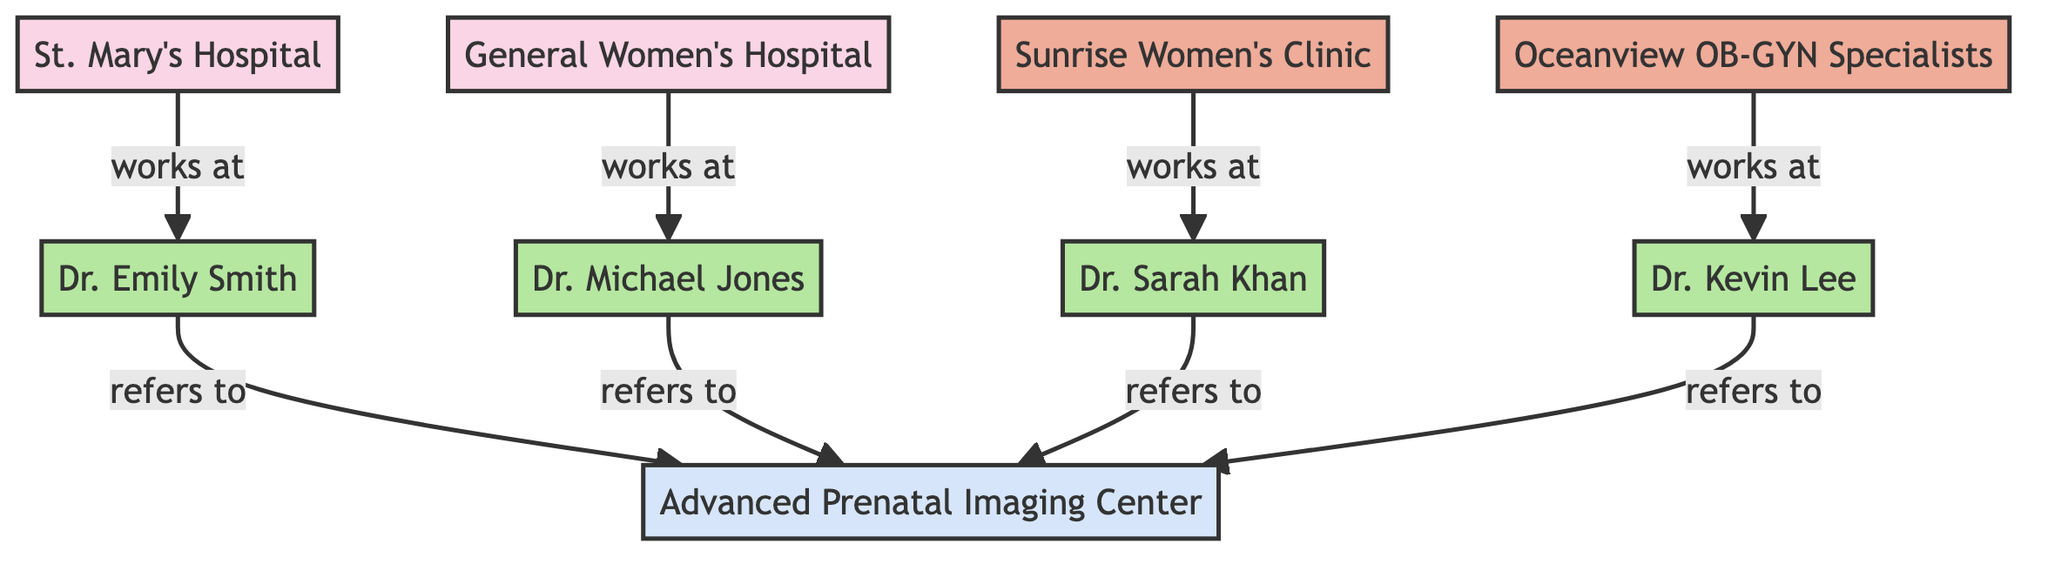What is the total number of hospitals in the diagram? There are two hospitals highlighted in the diagram: St. Mary's Hospital and General Women's Hospital. Therefore, by counting these entities, the total comes to two.
Answer: 2 Which doctor works at Sunrise Women's Clinic? The diagram clearly states that Dr. Sarah Khan works at Sunrise Women's Clinic, as indicated by the edge labeled "works at" leading from the clinic to the doctor.
Answer: Dr. Sarah Khan How many doctors refer patients to the Advanced Prenatal Imaging Center? The diagram outlines that all four doctors (Dr. Emily Smith, Dr. Michael Jones, Dr. Sarah Khan, and Dr. Kevin Lee) have edges labeled "refers to" leading to the ultrasound center. Therefore, counting these edges will reveal four referring doctors.
Answer: 4 What is the relationship between Dr. Emily Smith and St. Mary's Hospital? The diagram illustrates that Dr. Emily Smith works at St. Mary's Hospital, as indicated by the edge labeled "works at" connecting these two nodes.
Answer: works at Which clinic is associated with Dr. Kevin Lee? The diagram shows that Dr. Kevin Lee works at Oceanview OB-GYN Specialists, evident from the edge labeled "works at" linking the doctor to the clinic.
Answer: Oceanview OB-GYN Specialists What type of facility is the Advanced Prenatal Imaging Center? The diagram classifies the Advanced Prenatal Imaging Center as an ultrasound center, signified by its specific label in the node type.
Answer: Ultrasound Center How many total edges are present in the diagram? By examining the edges connecting the nodes, we observe there are eight total edges: four for "works at" relationships and four for "refers to" relationships. Therefore, the count comes to eight.
Answer: 8 Which doctor has the most direct connections to referral pathways? Analyzing the diagram, we see that each of the four doctors has a direct connection to the Advanced Prenatal Imaging Center, indicating equal direct referral paths. Since they each refer to the same center without others having special connections, the answer is all four doctors.
Answer: All four doctors What type of node is Dr. Michael Jones classified as? According to the diagram’s labeling, Dr. Michael Jones is classified under the type "OB-GYN," as indicated directly adjacent to his name in the node.
Answer: OB-GYN 